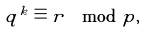<formula> <loc_0><loc_0><loc_500><loc_500>q ^ { k } \equiv r \mod p ,</formula> 